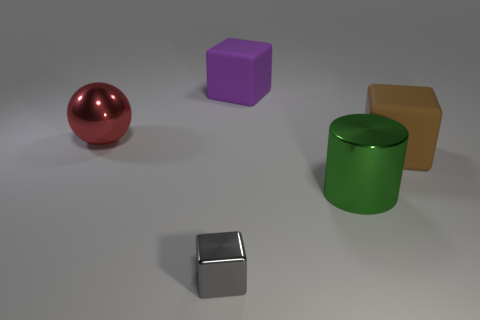Is there anything else that has the same size as the metal block?
Your answer should be very brief. No. What shape is the red thing that is the same material as the tiny gray object?
Your response must be concise. Sphere. There is a shiny object that is in front of the large cylinder; what is its size?
Your answer should be compact. Small. There is a red thing; what shape is it?
Offer a terse response. Sphere. Does the metallic object to the right of the gray object have the same size as the thing in front of the large shiny cylinder?
Offer a terse response. No. There is a matte thing in front of the large object that is on the left side of the block that is behind the red metal sphere; what is its size?
Your response must be concise. Large. The big shiny object in front of the red metallic thing behind the large matte block in front of the purple thing is what shape?
Offer a very short reply. Cylinder. There is a big matte object that is in front of the large purple cube; what shape is it?
Make the answer very short. Cube. Is the material of the brown cube the same as the large cube that is left of the cylinder?
Keep it short and to the point. Yes. What number of other objects are there of the same shape as the big brown rubber thing?
Your answer should be compact. 2. 